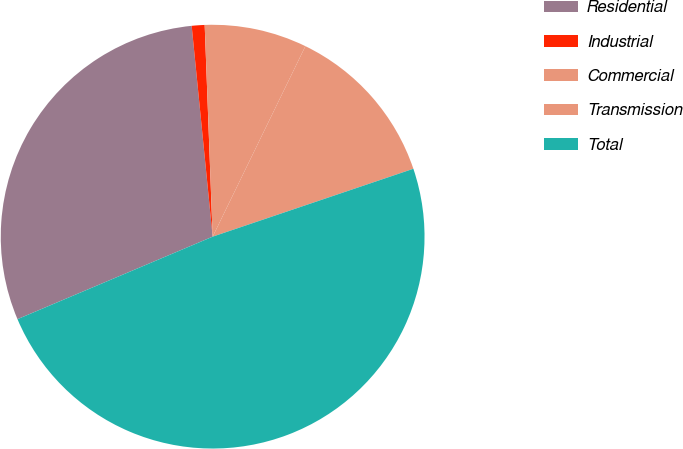Convert chart. <chart><loc_0><loc_0><loc_500><loc_500><pie_chart><fcel>Residential<fcel>Industrial<fcel>Commercial<fcel>Transmission<fcel>Total<nl><fcel>29.79%<fcel>0.98%<fcel>7.81%<fcel>12.6%<fcel>48.83%<nl></chart> 